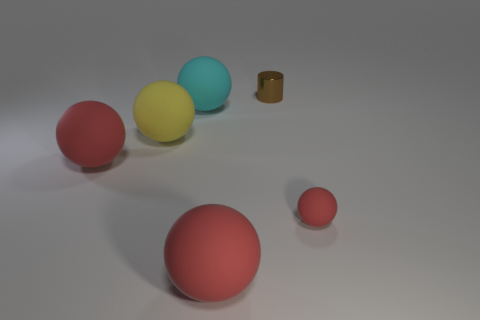Subtract all red cylinders. How many red balls are left? 3 Subtract all big spheres. How many spheres are left? 1 Subtract all yellow spheres. How many spheres are left? 4 Add 1 small gray things. How many objects exist? 7 Subtract all gray spheres. Subtract all red cubes. How many spheres are left? 5 Subtract all spheres. How many objects are left? 1 Add 6 large balls. How many large balls are left? 10 Add 1 purple cylinders. How many purple cylinders exist? 1 Subtract 0 green cylinders. How many objects are left? 6 Subtract all big red rubber objects. Subtract all tiny objects. How many objects are left? 2 